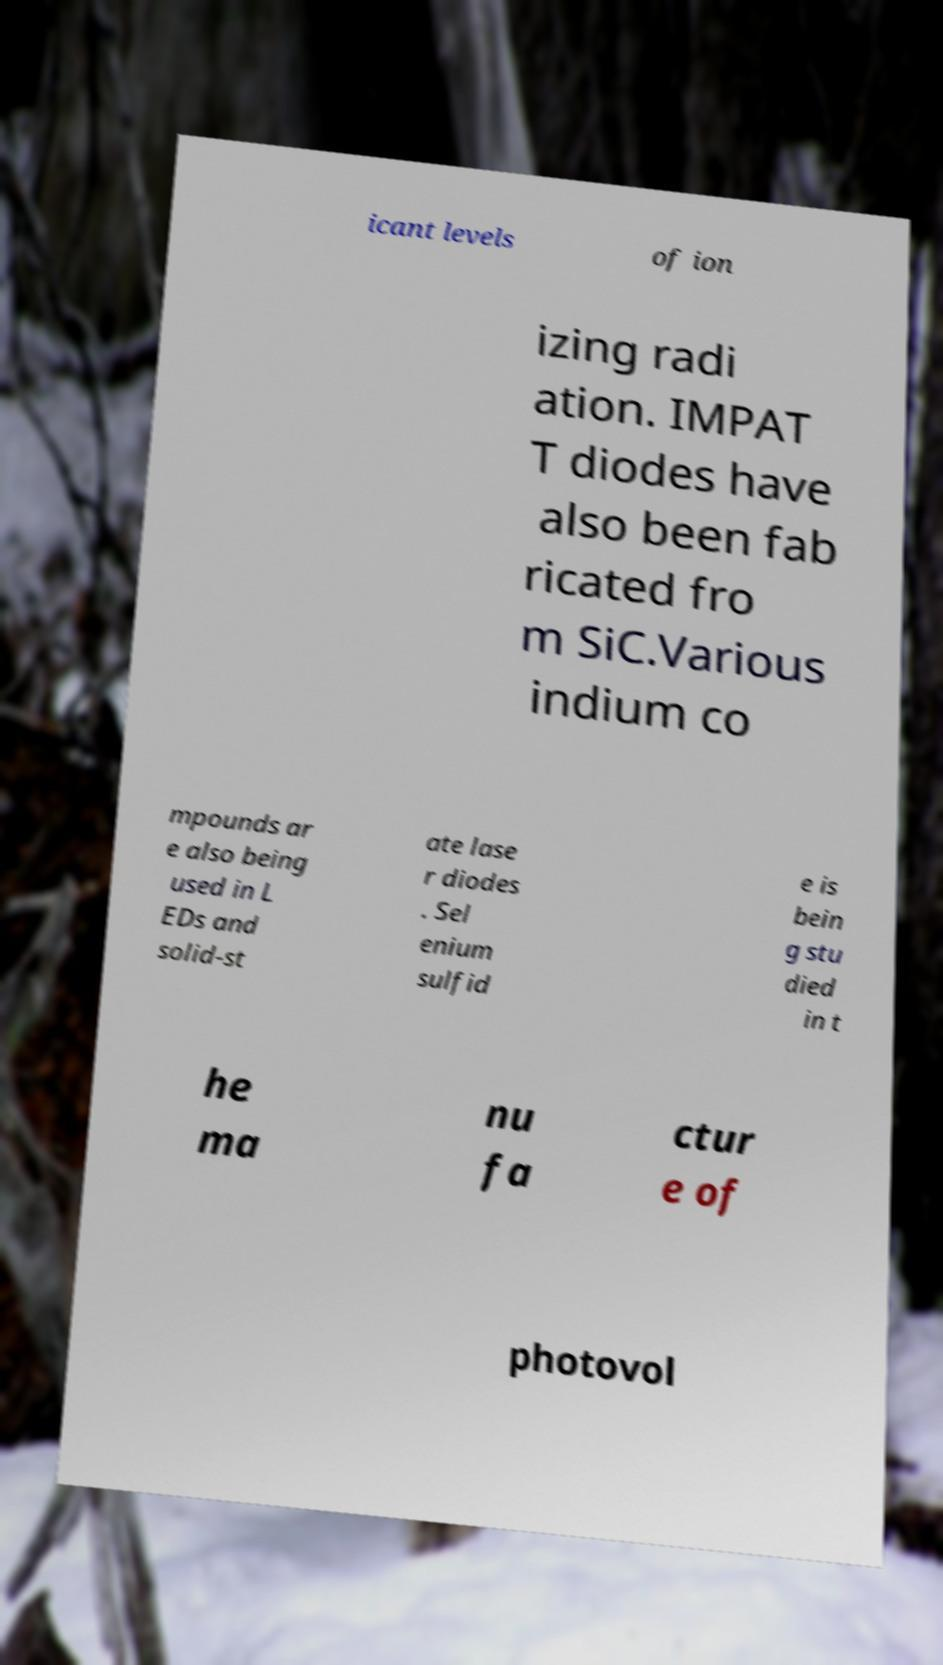Can you read and provide the text displayed in the image?This photo seems to have some interesting text. Can you extract and type it out for me? icant levels of ion izing radi ation. IMPAT T diodes have also been fab ricated fro m SiC.Various indium co mpounds ar e also being used in L EDs and solid-st ate lase r diodes . Sel enium sulfid e is bein g stu died in t he ma nu fa ctur e of photovol 